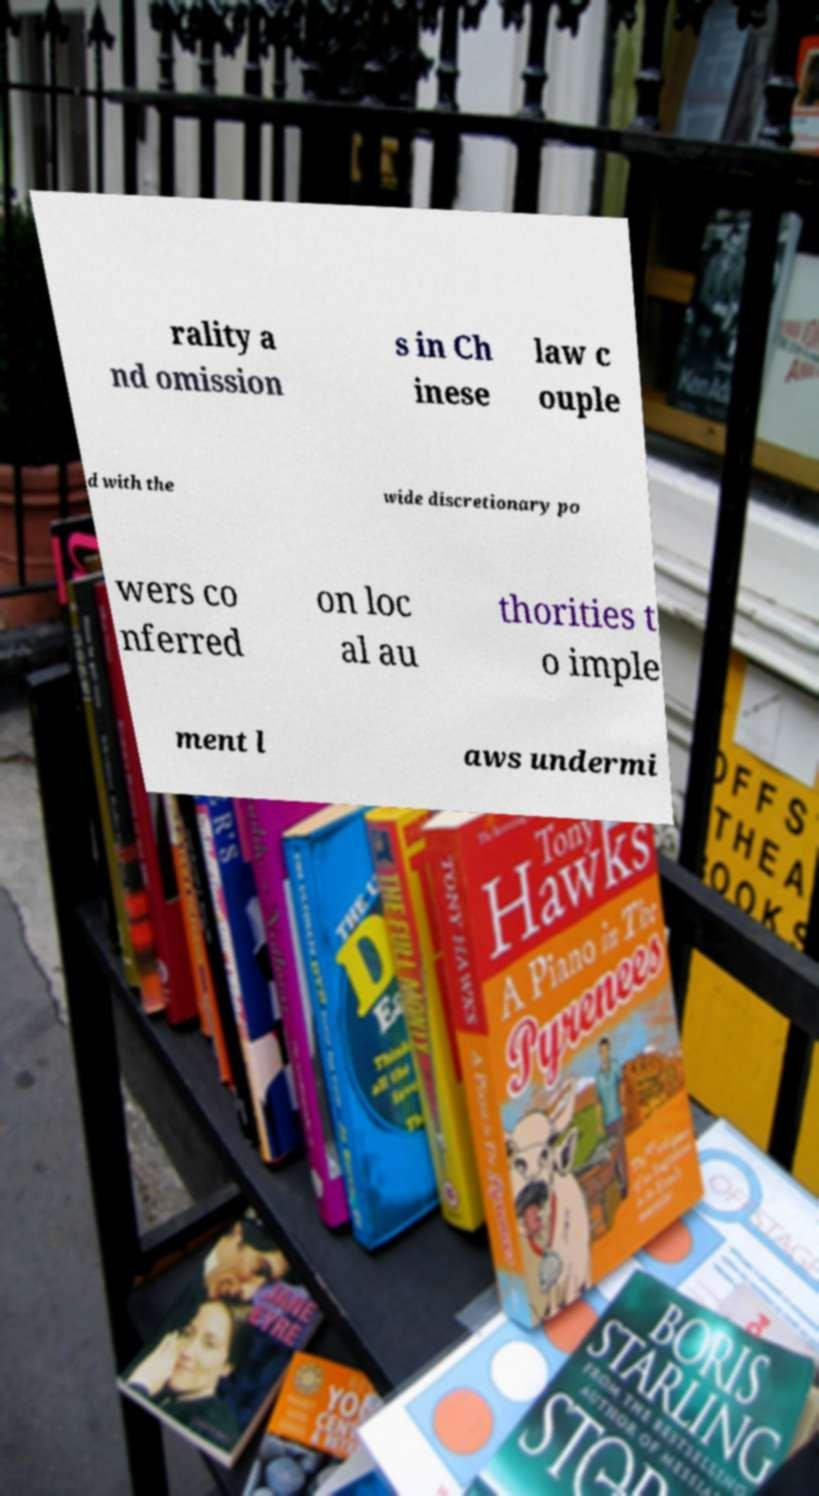There's text embedded in this image that I need extracted. Can you transcribe it verbatim? rality a nd omission s in Ch inese law c ouple d with the wide discretionary po wers co nferred on loc al au thorities t o imple ment l aws undermi 